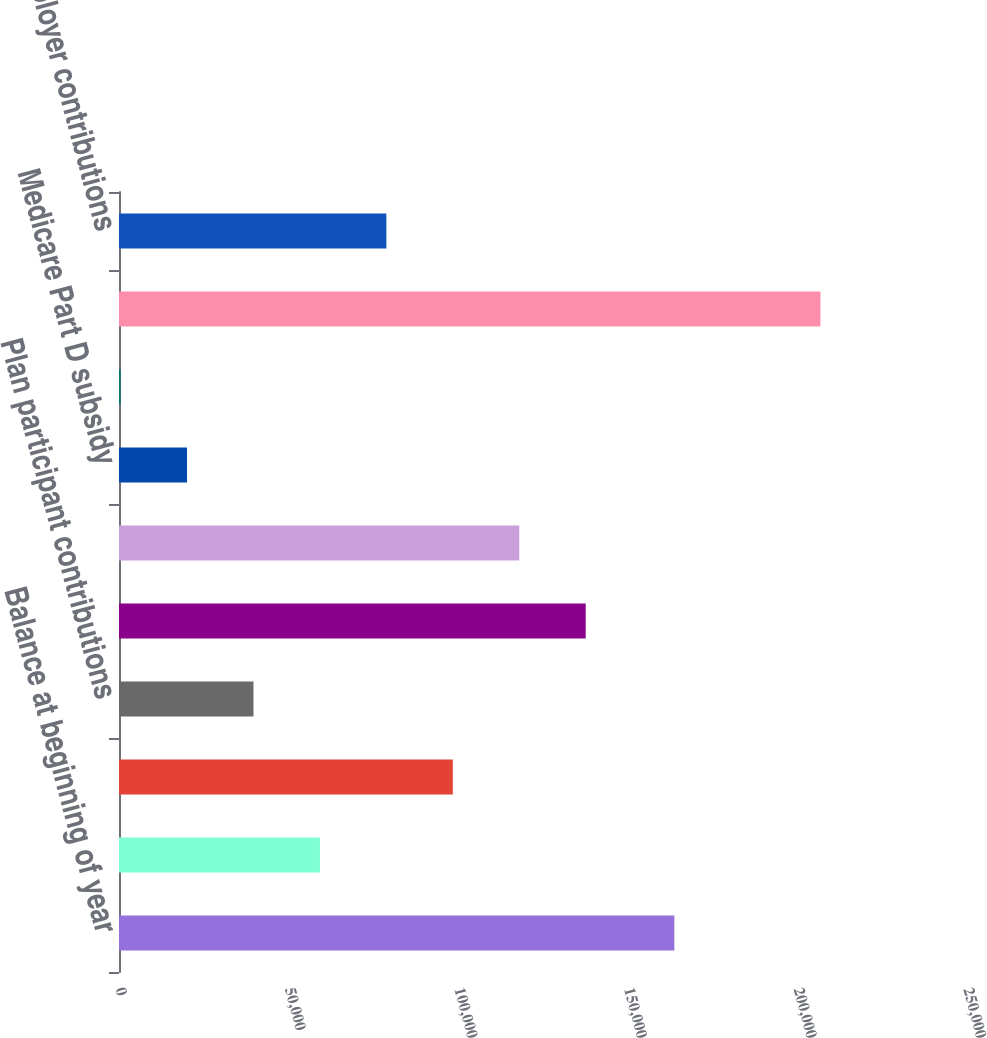Convert chart. <chart><loc_0><loc_0><loc_500><loc_500><bar_chart><fcel>Balance at beginning of year<fcel>Service cost<fcel>Interest cost<fcel>Plan participant contributions<fcel>Actuarial (gain)/loss<fcel>Benefits paid<fcel>Medicare Part D subsidy<fcel>Early Retiree Reinsurance<fcel>Balance at end of year<fcel>Employer contributions<nl><fcel>163720<fcel>59234.6<fcel>98411<fcel>39646.4<fcel>137587<fcel>117999<fcel>20058.2<fcel>470<fcel>206797<fcel>78822.8<nl></chart> 